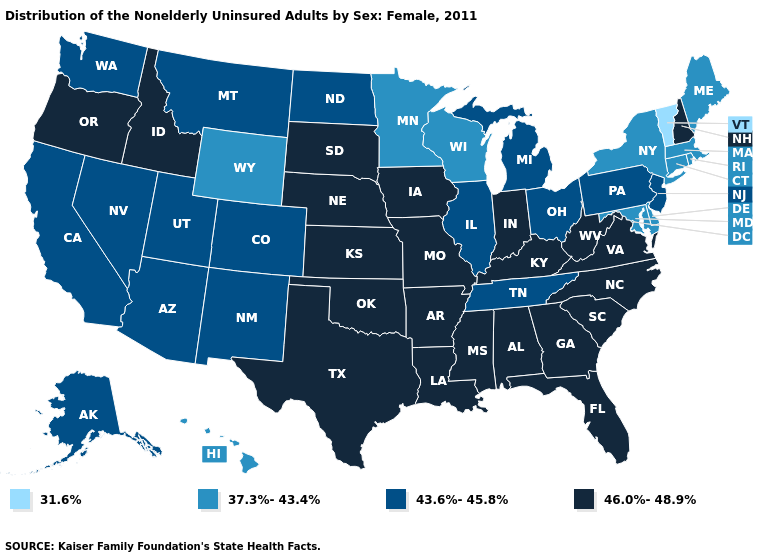What is the value of Tennessee?
Quick response, please. 43.6%-45.8%. Among the states that border Wisconsin , does Minnesota have the lowest value?
Concise answer only. Yes. Name the states that have a value in the range 37.3%-43.4%?
Write a very short answer. Connecticut, Delaware, Hawaii, Maine, Maryland, Massachusetts, Minnesota, New York, Rhode Island, Wisconsin, Wyoming. Name the states that have a value in the range 46.0%-48.9%?
Concise answer only. Alabama, Arkansas, Florida, Georgia, Idaho, Indiana, Iowa, Kansas, Kentucky, Louisiana, Mississippi, Missouri, Nebraska, New Hampshire, North Carolina, Oklahoma, Oregon, South Carolina, South Dakota, Texas, Virginia, West Virginia. Does Oklahoma have a higher value than Texas?
Concise answer only. No. What is the value of Tennessee?
Answer briefly. 43.6%-45.8%. What is the highest value in the West ?
Keep it brief. 46.0%-48.9%. What is the value of Oklahoma?
Write a very short answer. 46.0%-48.9%. Does Delaware have the lowest value in the South?
Concise answer only. Yes. Does Nevada have the highest value in the West?
Write a very short answer. No. Which states hav the highest value in the MidWest?
Keep it brief. Indiana, Iowa, Kansas, Missouri, Nebraska, South Dakota. What is the lowest value in the USA?
Concise answer only. 31.6%. What is the value of West Virginia?
Answer briefly. 46.0%-48.9%. Does the first symbol in the legend represent the smallest category?
Keep it brief. Yes. What is the lowest value in states that border Mississippi?
Answer briefly. 43.6%-45.8%. 